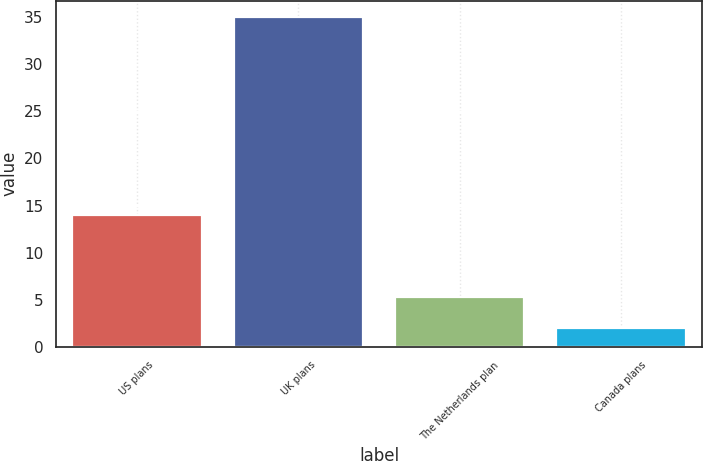<chart> <loc_0><loc_0><loc_500><loc_500><bar_chart><fcel>US plans<fcel>UK plans<fcel>The Netherlands plan<fcel>Canada plans<nl><fcel>14<fcel>35<fcel>5.3<fcel>2<nl></chart> 